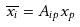<formula> <loc_0><loc_0><loc_500><loc_500>\overline { x _ { i } } = A _ { i p } x _ { p }</formula> 